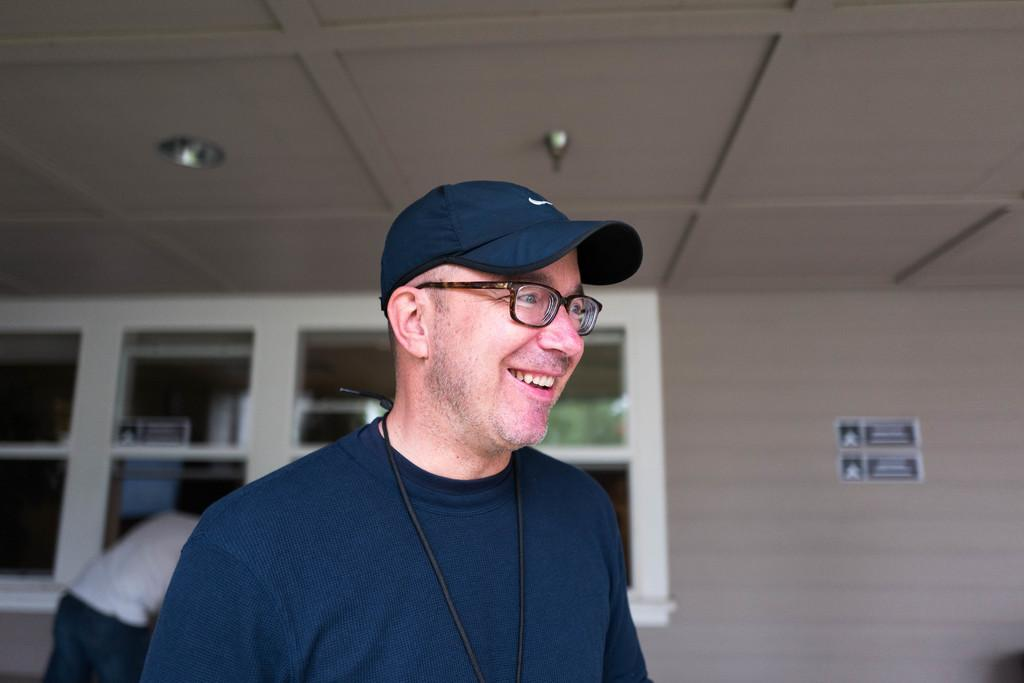What is the person in the foreground of the image doing? The person is standing and smiling in the image. What can be seen in the background of the image? There is a wall, a window, and another person in the background of the image. What part of the room is visible at the top of the image? The ceiling is visible at the top of the image. What type of orange is being used as a hat by the person in the image? There is no orange present in the image, nor is anyone wearing an orange as a hat. 